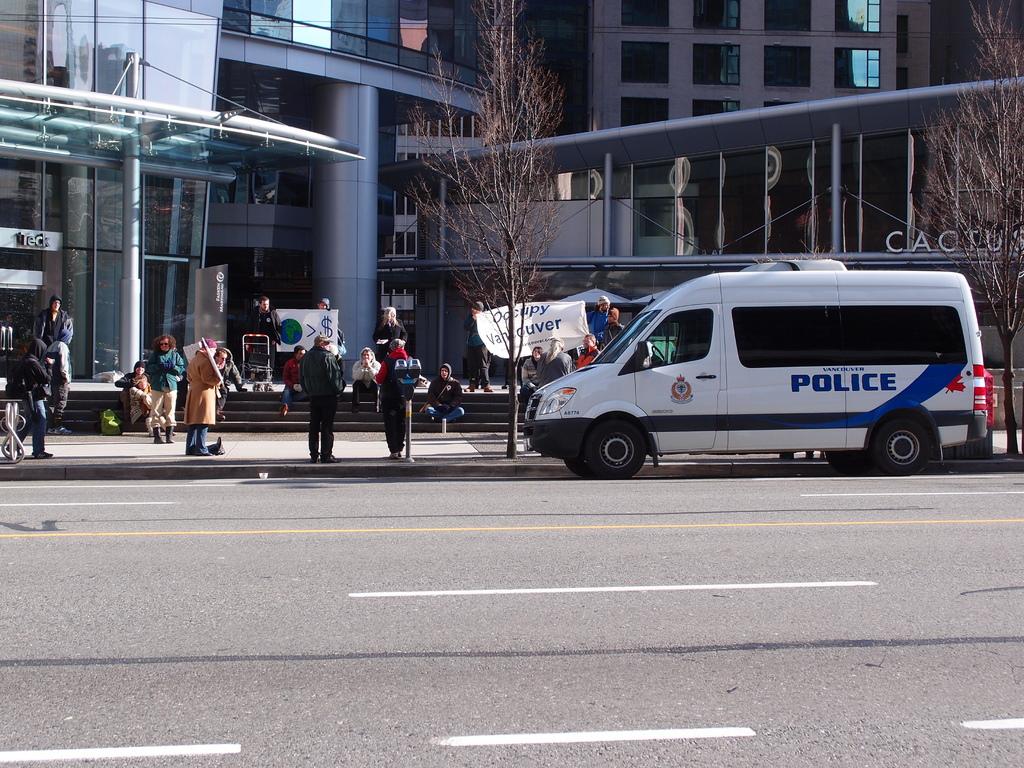What department is this van for?
Offer a very short reply. Police. What city is this according to the sign?
Your answer should be very brief. Vancouver. 